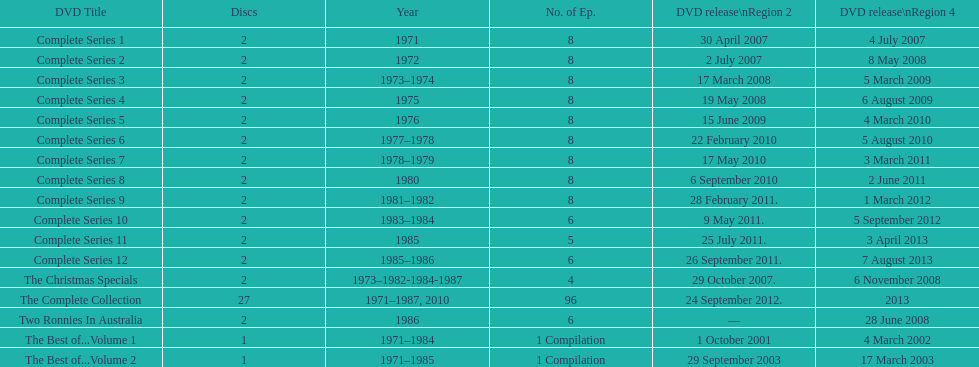In regards to the tv show "the two ronnies," how many "best of" volumes have been created to compile the top episodes? 2. 